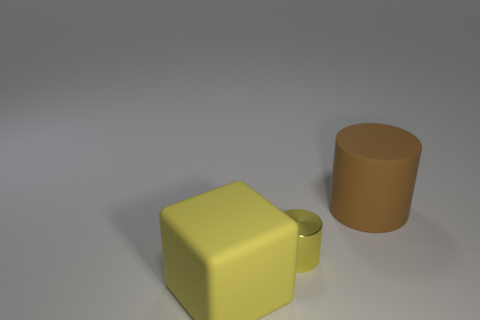What color is the thing that is on the left side of the brown rubber cylinder and behind the yellow matte thing?
Offer a terse response. Yellow. Is the number of big brown cylinders greater than the number of big blue rubber things?
Your answer should be compact. Yes. There is a big brown object that is on the right side of the tiny yellow metallic cylinder; is it the same shape as the small shiny thing?
Make the answer very short. Yes. How many shiny objects are either large objects or small red objects?
Offer a terse response. 0. Are there any gray cylinders made of the same material as the large yellow thing?
Offer a terse response. No. What is the material of the big yellow object?
Your response must be concise. Rubber. There is a yellow object left of the yellow object on the right side of the rubber thing that is in front of the brown object; what shape is it?
Offer a very short reply. Cube. Are there more yellow metal things that are in front of the brown rubber object than large green cylinders?
Your answer should be very brief. Yes. There is a big yellow matte thing; is it the same shape as the thing that is behind the yellow metallic cylinder?
Provide a short and direct response. No. The thing that is the same color as the small metallic cylinder is what shape?
Your answer should be very brief. Cube. 